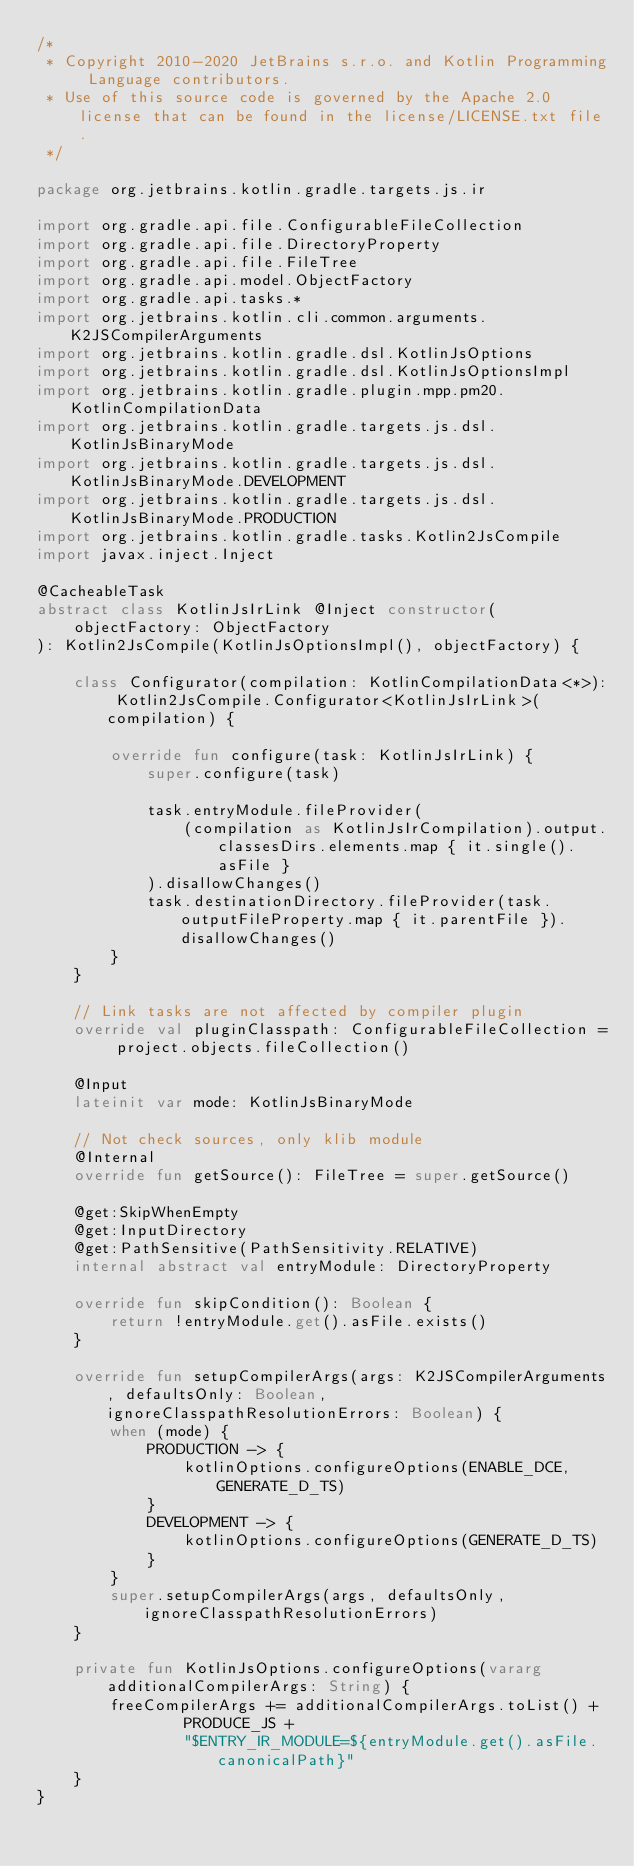<code> <loc_0><loc_0><loc_500><loc_500><_Kotlin_>/*
 * Copyright 2010-2020 JetBrains s.r.o. and Kotlin Programming Language contributors.
 * Use of this source code is governed by the Apache 2.0 license that can be found in the license/LICENSE.txt file.
 */

package org.jetbrains.kotlin.gradle.targets.js.ir

import org.gradle.api.file.ConfigurableFileCollection
import org.gradle.api.file.DirectoryProperty
import org.gradle.api.file.FileTree
import org.gradle.api.model.ObjectFactory
import org.gradle.api.tasks.*
import org.jetbrains.kotlin.cli.common.arguments.K2JSCompilerArguments
import org.jetbrains.kotlin.gradle.dsl.KotlinJsOptions
import org.jetbrains.kotlin.gradle.dsl.KotlinJsOptionsImpl
import org.jetbrains.kotlin.gradle.plugin.mpp.pm20.KotlinCompilationData
import org.jetbrains.kotlin.gradle.targets.js.dsl.KotlinJsBinaryMode
import org.jetbrains.kotlin.gradle.targets.js.dsl.KotlinJsBinaryMode.DEVELOPMENT
import org.jetbrains.kotlin.gradle.targets.js.dsl.KotlinJsBinaryMode.PRODUCTION
import org.jetbrains.kotlin.gradle.tasks.Kotlin2JsCompile
import javax.inject.Inject

@CacheableTask
abstract class KotlinJsIrLink @Inject constructor(
    objectFactory: ObjectFactory
): Kotlin2JsCompile(KotlinJsOptionsImpl(), objectFactory) {

    class Configurator(compilation: KotlinCompilationData<*>): Kotlin2JsCompile.Configurator<KotlinJsIrLink>(compilation) {

        override fun configure(task: KotlinJsIrLink) {
            super.configure(task)

            task.entryModule.fileProvider(
                (compilation as KotlinJsIrCompilation).output.classesDirs.elements.map { it.single().asFile }
            ).disallowChanges()
            task.destinationDirectory.fileProvider(task.outputFileProperty.map { it.parentFile }).disallowChanges()
        }
    }

    // Link tasks are not affected by compiler plugin
    override val pluginClasspath: ConfigurableFileCollection = project.objects.fileCollection()

    @Input
    lateinit var mode: KotlinJsBinaryMode

    // Not check sources, only klib module
    @Internal
    override fun getSource(): FileTree = super.getSource()

    @get:SkipWhenEmpty
    @get:InputDirectory
    @get:PathSensitive(PathSensitivity.RELATIVE)
    internal abstract val entryModule: DirectoryProperty

    override fun skipCondition(): Boolean {
        return !entryModule.get().asFile.exists()
    }

    override fun setupCompilerArgs(args: K2JSCompilerArguments, defaultsOnly: Boolean, ignoreClasspathResolutionErrors: Boolean) {
        when (mode) {
            PRODUCTION -> {
                kotlinOptions.configureOptions(ENABLE_DCE, GENERATE_D_TS)
            }
            DEVELOPMENT -> {
                kotlinOptions.configureOptions(GENERATE_D_TS)
            }
        }
        super.setupCompilerArgs(args, defaultsOnly, ignoreClasspathResolutionErrors)
    }

    private fun KotlinJsOptions.configureOptions(vararg additionalCompilerArgs: String) {
        freeCompilerArgs += additionalCompilerArgs.toList() +
                PRODUCE_JS +
                "$ENTRY_IR_MODULE=${entryModule.get().asFile.canonicalPath}"
    }
}
</code> 